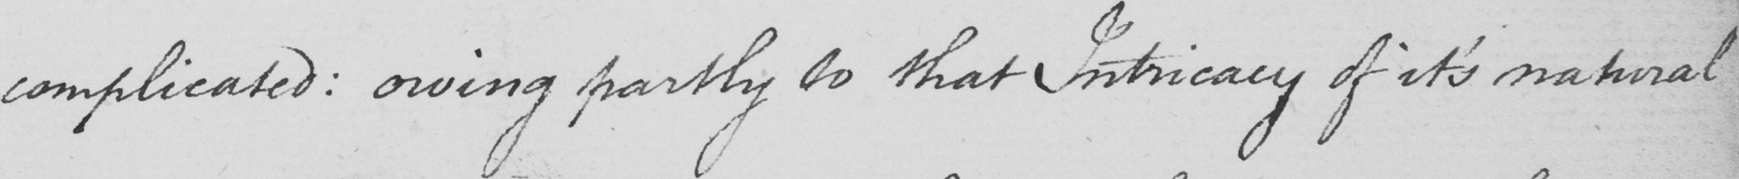Transcribe the text shown in this historical manuscript line. complicated :  owing partly to what Intricacy of it ' s natural 